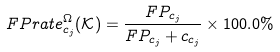Convert formula to latex. <formula><loc_0><loc_0><loc_500><loc_500>F P r a t e ^ { \Omega } _ { c _ { j } } ( \mathcal { K } ) = \frac { F P _ { c _ { j } } } { F P _ { c _ { j } } + c _ { c _ { j } } } \times 1 0 0 . 0 \%</formula> 